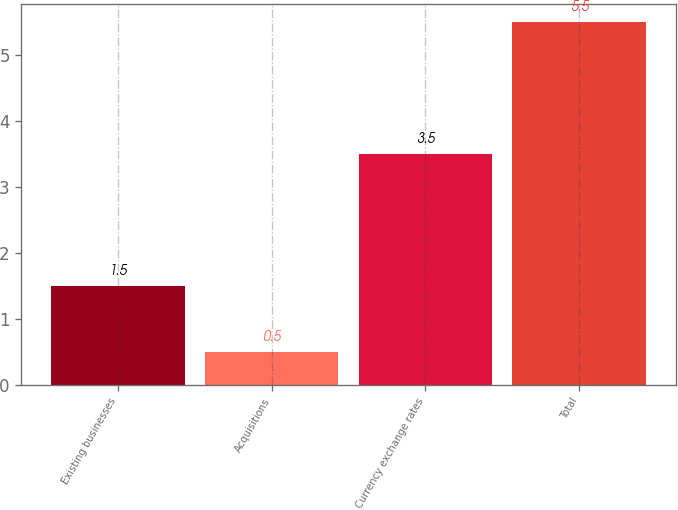<chart> <loc_0><loc_0><loc_500><loc_500><bar_chart><fcel>Existing businesses<fcel>Acquisitions<fcel>Currency exchange rates<fcel>Total<nl><fcel>1.5<fcel>0.5<fcel>3.5<fcel>5.5<nl></chart> 